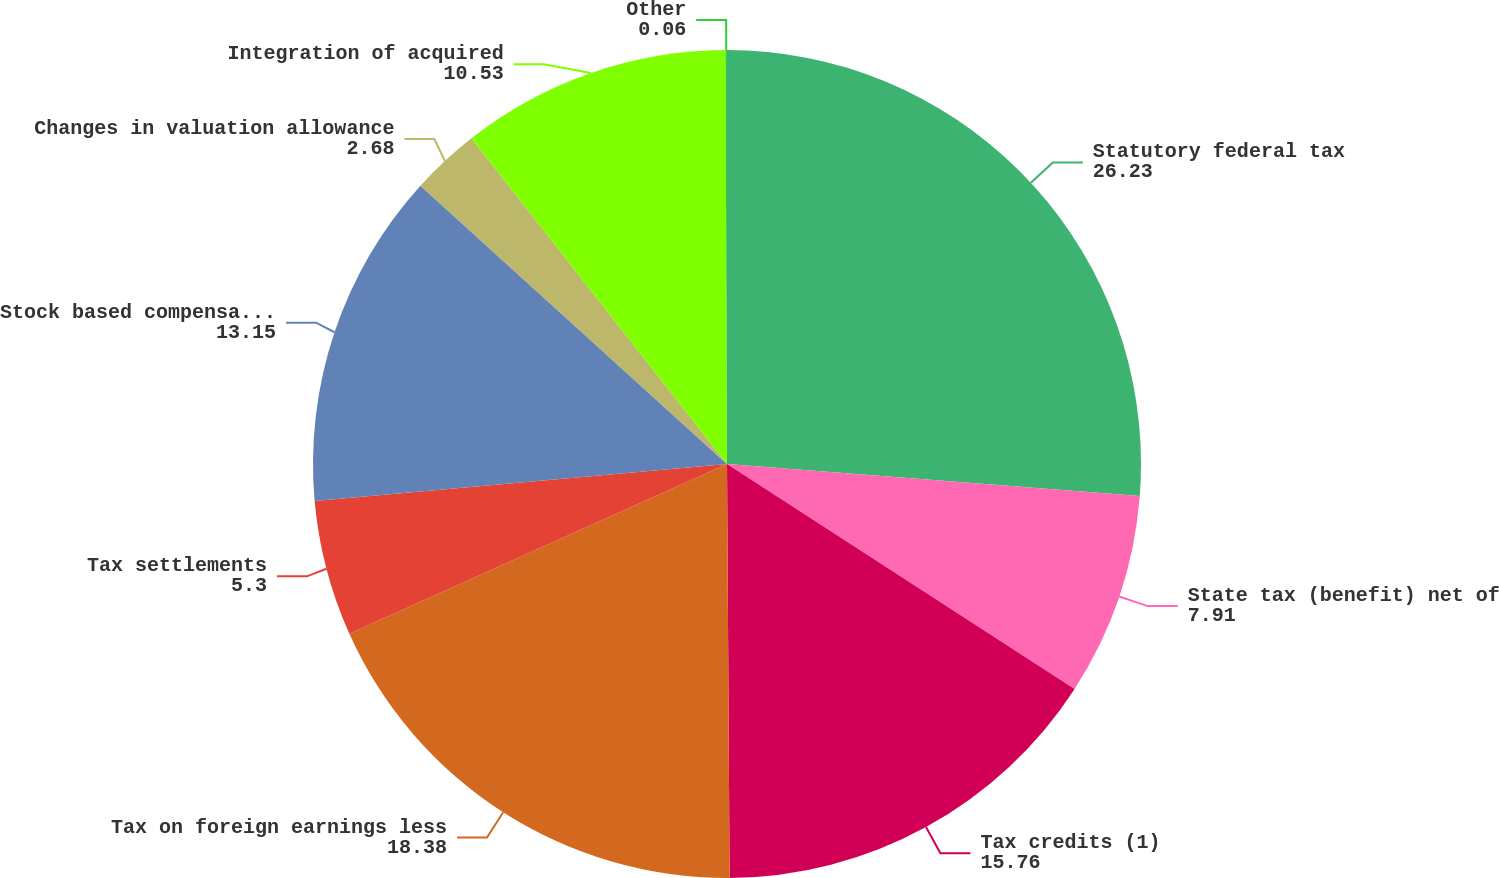Convert chart to OTSL. <chart><loc_0><loc_0><loc_500><loc_500><pie_chart><fcel>Statutory federal tax<fcel>State tax (benefit) net of<fcel>Tax credits (1)<fcel>Tax on foreign earnings less<fcel>Tax settlements<fcel>Stock based compensation<fcel>Changes in valuation allowance<fcel>Integration of acquired<fcel>Other<nl><fcel>26.23%<fcel>7.91%<fcel>15.76%<fcel>18.38%<fcel>5.3%<fcel>13.15%<fcel>2.68%<fcel>10.53%<fcel>0.06%<nl></chart> 